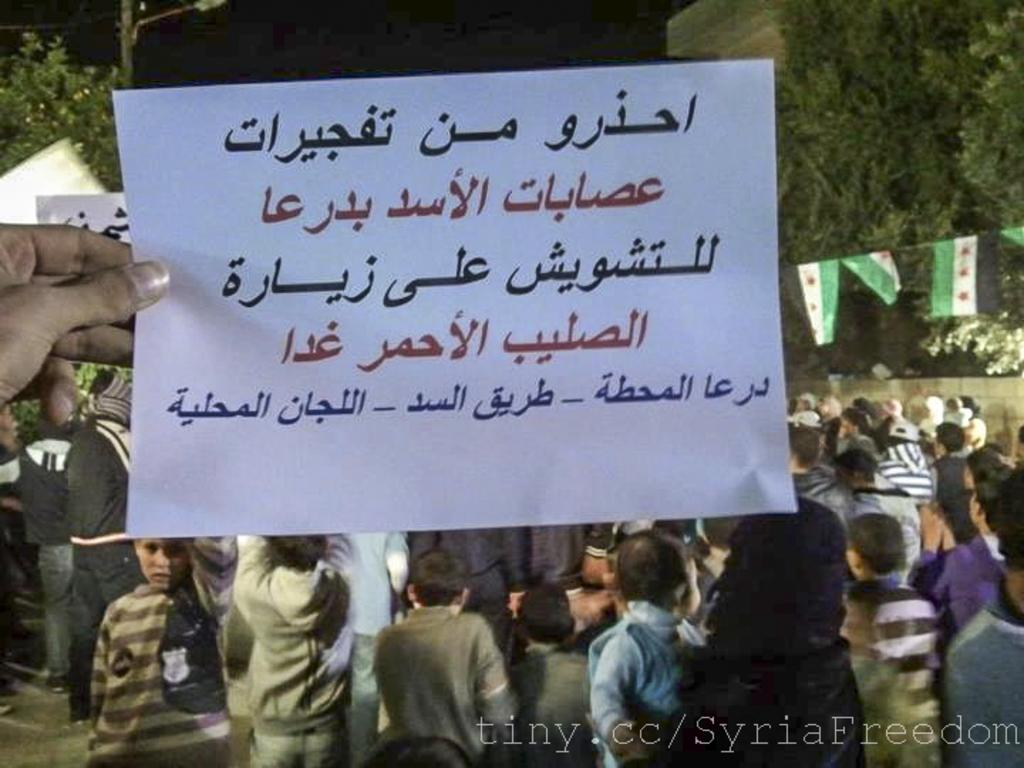What is the color of the paper visible in the image? The paper in the image is white. What can be seen in the background of the image? There are people standing and green color trees in the background of the image. Is there a crown visible on the paper in the image? No, there is no crown present on the paper in the image. What is the tendency of the people standing in the background of the image? The provided facts do not give any information about the people's tendencies, so we cannot answer this question. 